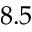<formula> <loc_0><loc_0><loc_500><loc_500>8 . 5</formula> 